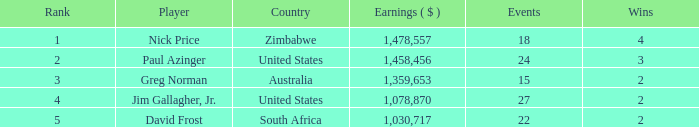How many events are in South Africa? 22.0. 